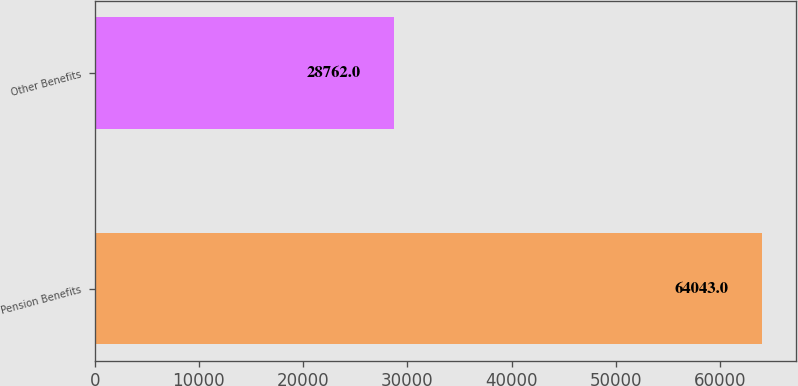<chart> <loc_0><loc_0><loc_500><loc_500><bar_chart><fcel>Pension Benefits<fcel>Other Benefits<nl><fcel>64043<fcel>28762<nl></chart> 